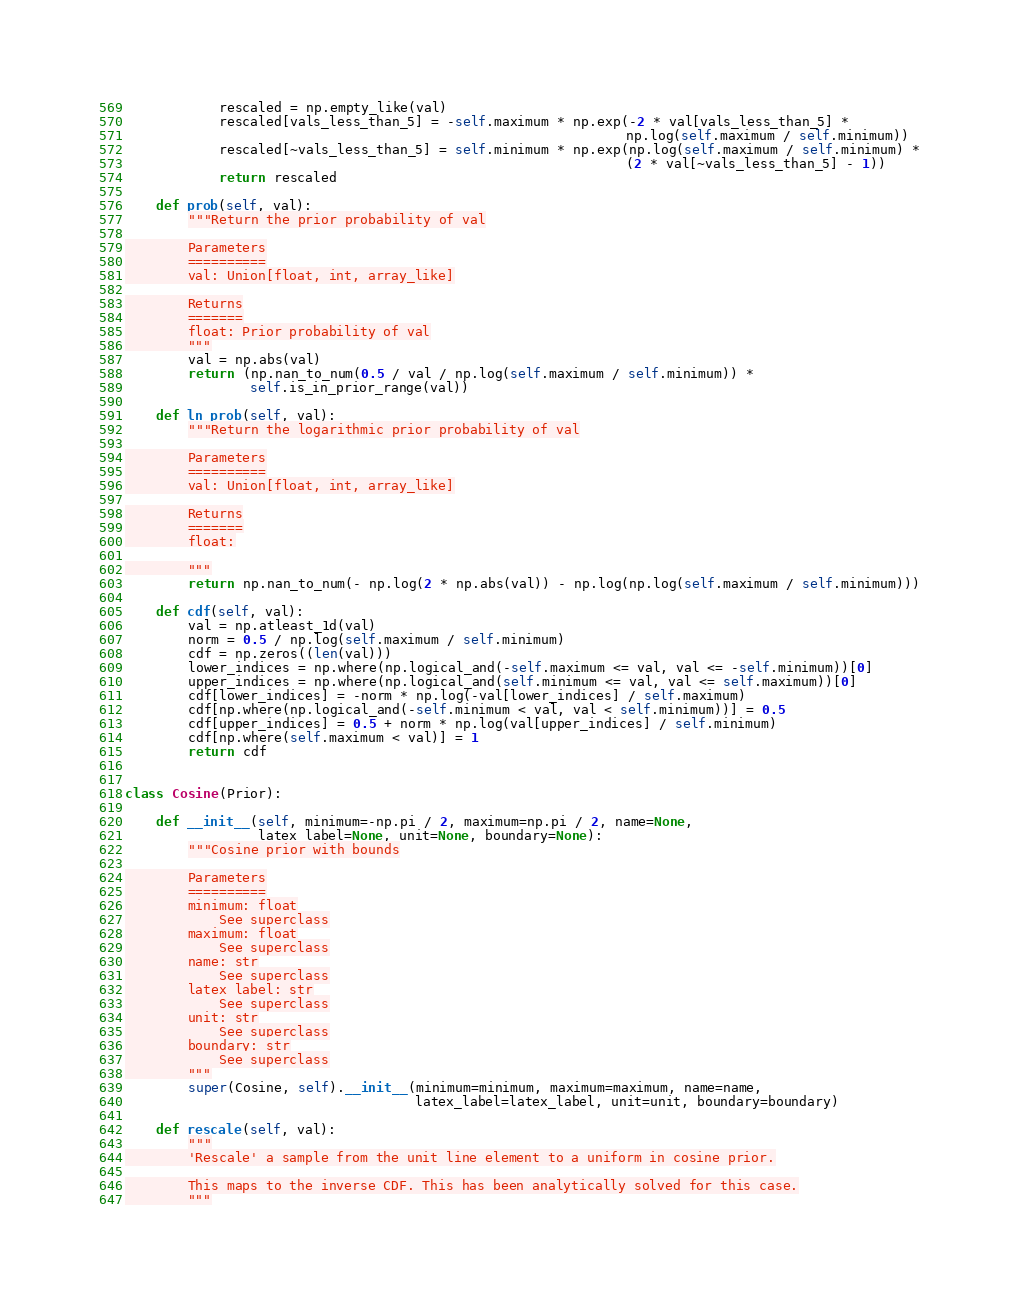Convert code to text. <code><loc_0><loc_0><loc_500><loc_500><_Python_>            rescaled = np.empty_like(val)
            rescaled[vals_less_than_5] = -self.maximum * np.exp(-2 * val[vals_less_than_5] *
                                                                np.log(self.maximum / self.minimum))
            rescaled[~vals_less_than_5] = self.minimum * np.exp(np.log(self.maximum / self.minimum) *
                                                                (2 * val[~vals_less_than_5] - 1))
            return rescaled

    def prob(self, val):
        """Return the prior probability of val

        Parameters
        ==========
        val: Union[float, int, array_like]

        Returns
        =======
        float: Prior probability of val
        """
        val = np.abs(val)
        return (np.nan_to_num(0.5 / val / np.log(self.maximum / self.minimum)) *
                self.is_in_prior_range(val))

    def ln_prob(self, val):
        """Return the logarithmic prior probability of val

        Parameters
        ==========
        val: Union[float, int, array_like]

        Returns
        =======
        float:

        """
        return np.nan_to_num(- np.log(2 * np.abs(val)) - np.log(np.log(self.maximum / self.minimum)))

    def cdf(self, val):
        val = np.atleast_1d(val)
        norm = 0.5 / np.log(self.maximum / self.minimum)
        cdf = np.zeros((len(val)))
        lower_indices = np.where(np.logical_and(-self.maximum <= val, val <= -self.minimum))[0]
        upper_indices = np.where(np.logical_and(self.minimum <= val, val <= self.maximum))[0]
        cdf[lower_indices] = -norm * np.log(-val[lower_indices] / self.maximum)
        cdf[np.where(np.logical_and(-self.minimum < val, val < self.minimum))] = 0.5
        cdf[upper_indices] = 0.5 + norm * np.log(val[upper_indices] / self.minimum)
        cdf[np.where(self.maximum < val)] = 1
        return cdf


class Cosine(Prior):

    def __init__(self, minimum=-np.pi / 2, maximum=np.pi / 2, name=None,
                 latex_label=None, unit=None, boundary=None):
        """Cosine prior with bounds

        Parameters
        ==========
        minimum: float
            See superclass
        maximum: float
            See superclass
        name: str
            See superclass
        latex_label: str
            See superclass
        unit: str
            See superclass
        boundary: str
            See superclass
        """
        super(Cosine, self).__init__(minimum=minimum, maximum=maximum, name=name,
                                     latex_label=latex_label, unit=unit, boundary=boundary)

    def rescale(self, val):
        """
        'Rescale' a sample from the unit line element to a uniform in cosine prior.

        This maps to the inverse CDF. This has been analytically solved for this case.
        """</code> 